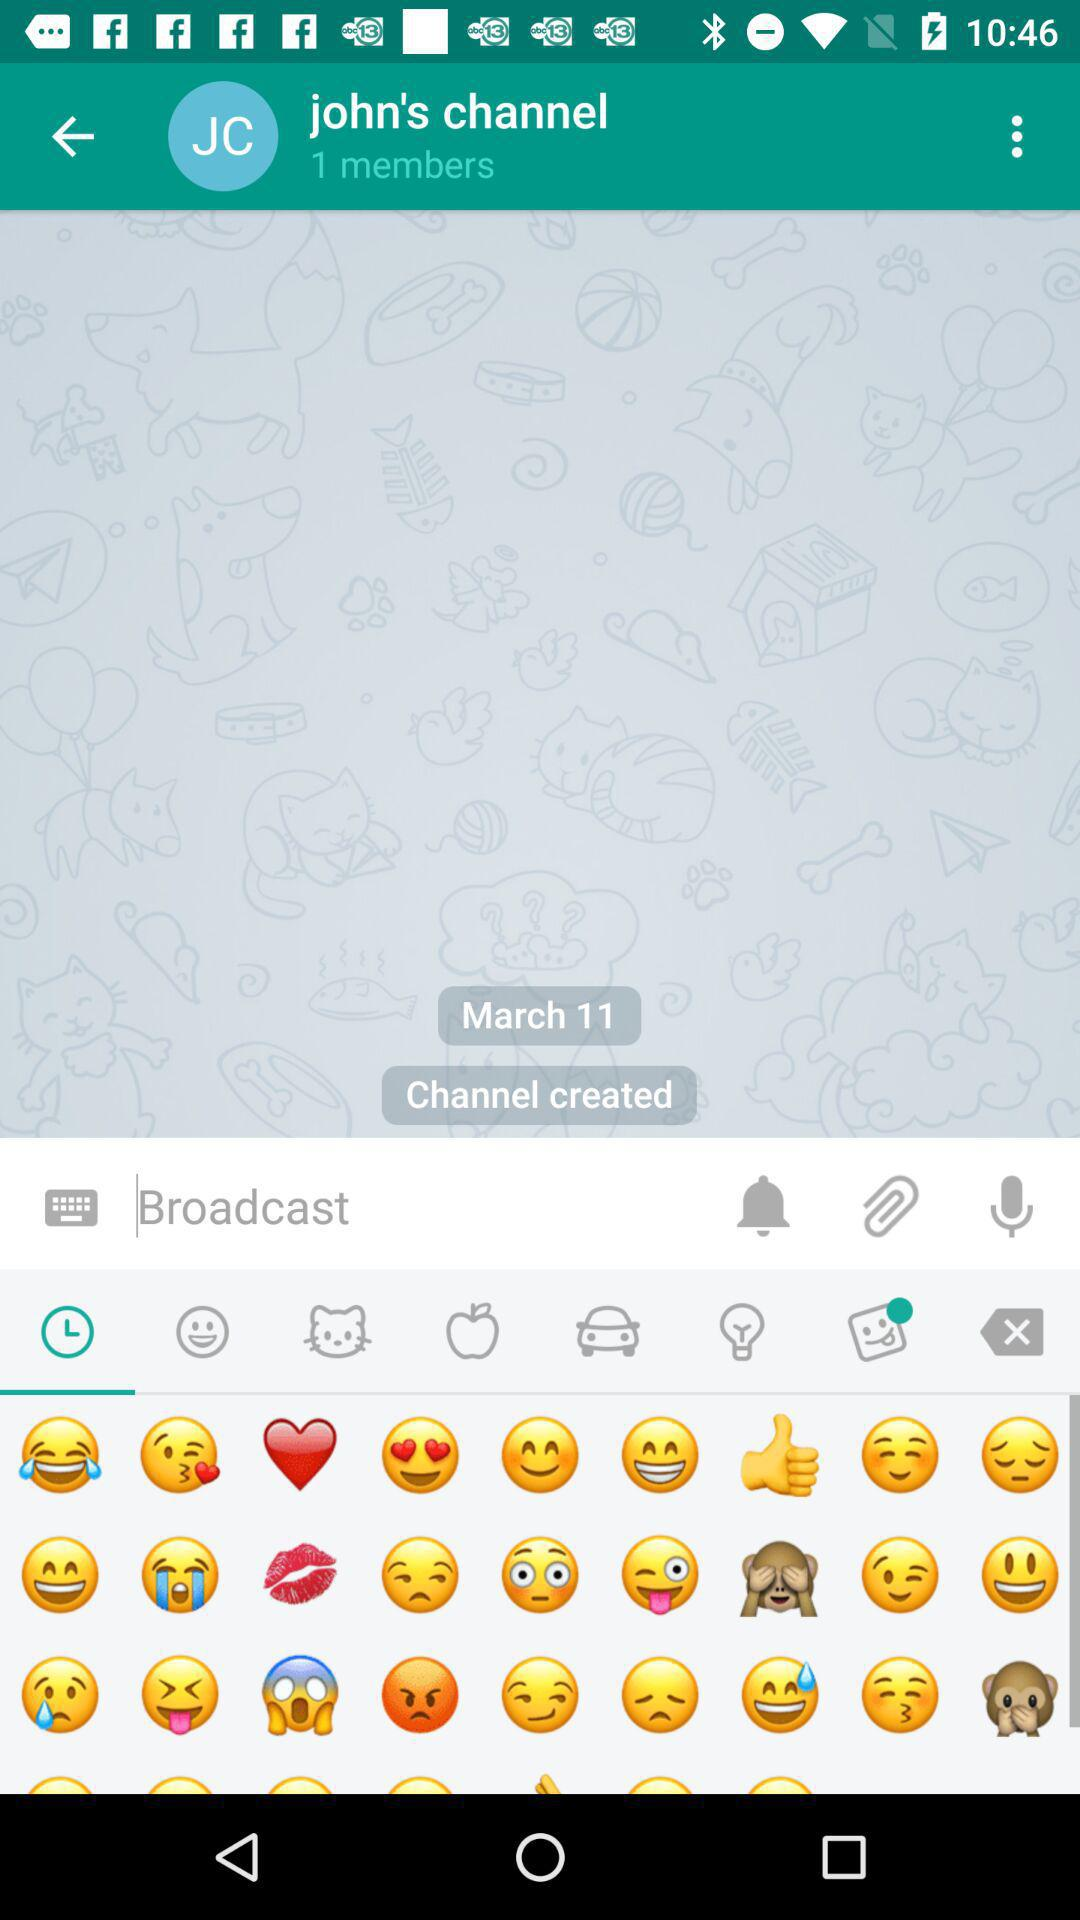What is the channel name? The channel name is "john's channel". 